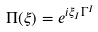<formula> <loc_0><loc_0><loc_500><loc_500>\Pi ( \xi ) = e ^ { i \xi _ { I } \Gamma ^ { I } }</formula> 